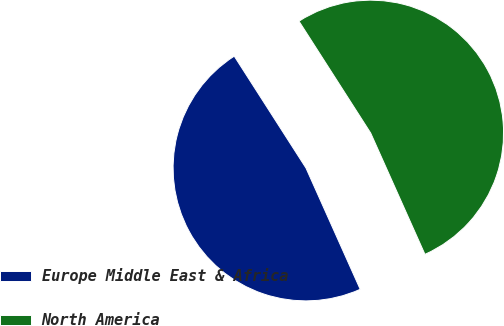Convert chart to OTSL. <chart><loc_0><loc_0><loc_500><loc_500><pie_chart><fcel>Europe Middle East & Africa<fcel>North America<nl><fcel>47.62%<fcel>52.38%<nl></chart> 